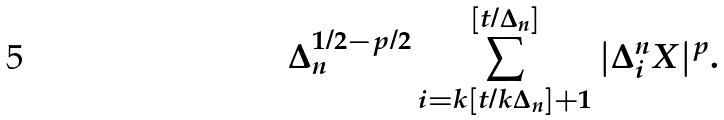Convert formula to latex. <formula><loc_0><loc_0><loc_500><loc_500>\Delta _ { n } ^ { 1 / 2 - p / 2 } \sum _ { i = k [ t / k \Delta _ { n } ] + 1 } ^ { [ t / \Delta _ { n } ] } | \Delta _ { i } ^ { n } X | ^ { p } .</formula> 